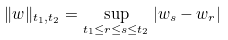Convert formula to latex. <formula><loc_0><loc_0><loc_500><loc_500>\| w \| _ { t _ { 1 } , t _ { 2 } } = \sup _ { t _ { 1 } \leq r \leq s \leq t _ { 2 } } | w _ { s } - w _ { r } |</formula> 